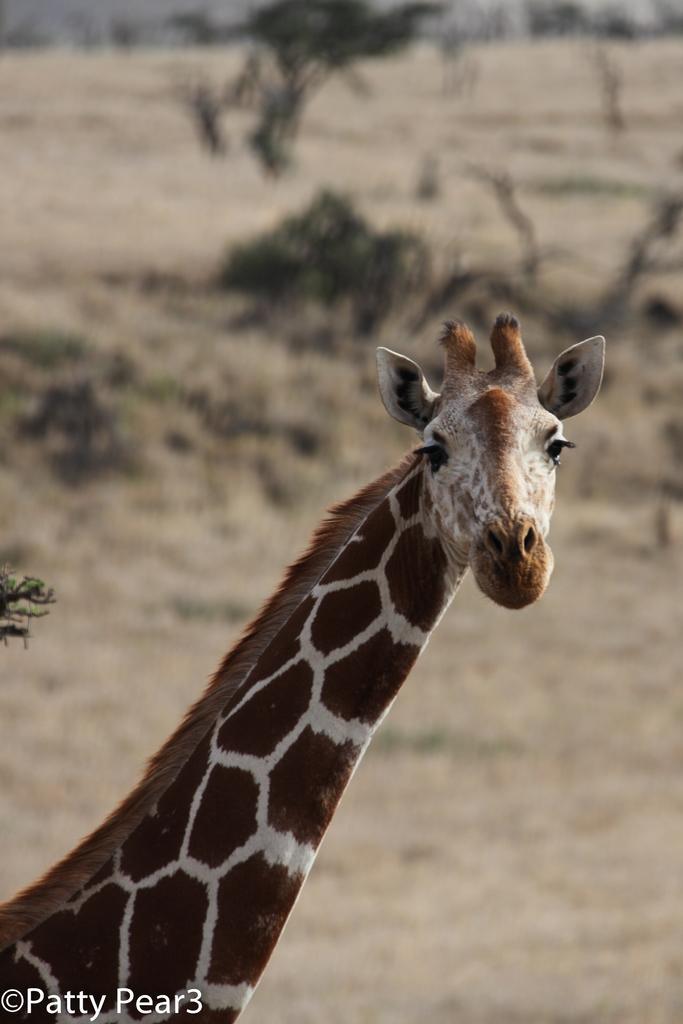Please provide a concise description of this image. In this image we can see a giraffe. On the backside we can see some trees. 